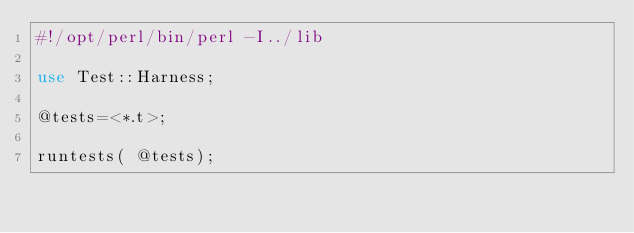Convert code to text. <code><loc_0><loc_0><loc_500><loc_500><_Perl_>#!/opt/perl/bin/perl -I../lib

use Test::Harness;

@tests=<*.t>;

runtests( @tests);
</code> 